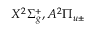Convert formula to latex. <formula><loc_0><loc_0><loc_500><loc_500>X ^ { 2 } \Sigma _ { g } ^ { + } , A ^ { 2 } \Pi _ { u \pm }</formula> 